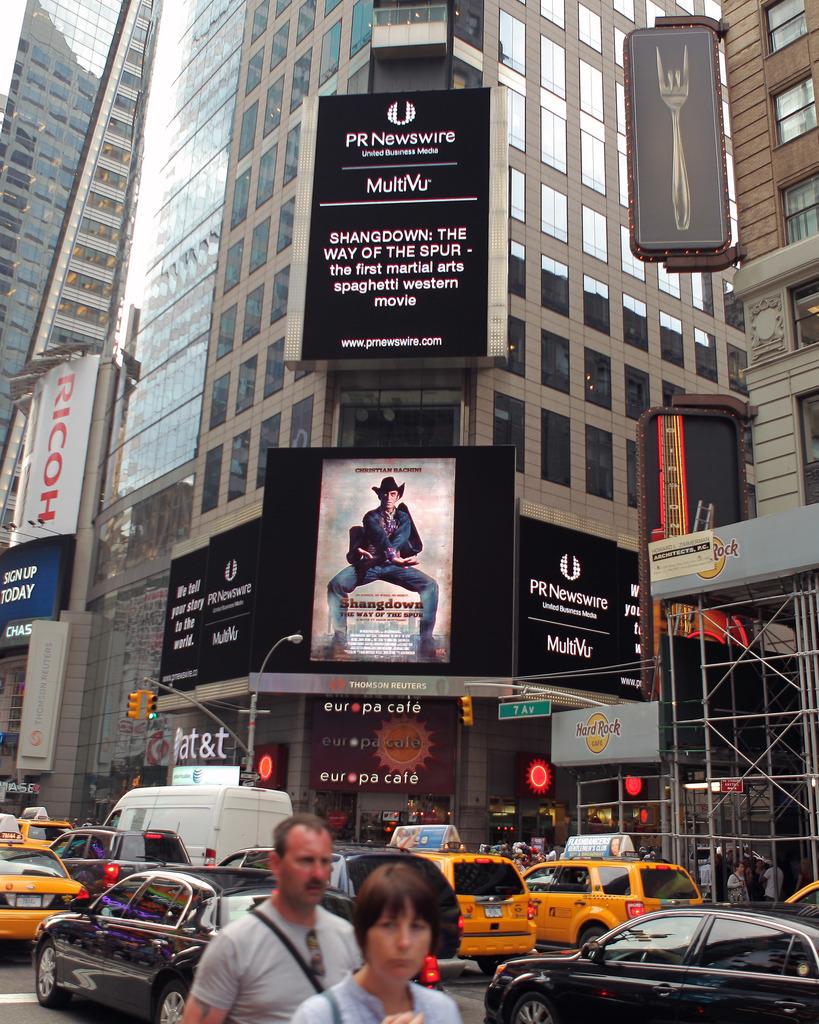Which street is indicated on the green sign?
Your response must be concise. 7 av. What movie is playing at the theater?
Your answer should be compact. Shangdown. 